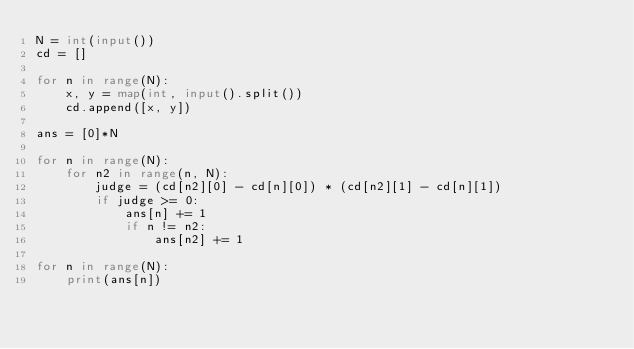<code> <loc_0><loc_0><loc_500><loc_500><_Python_>N = int(input())
cd = []

for n in range(N):
    x, y = map(int, input().split())
    cd.append([x, y])

ans = [0]*N

for n in range(N):
    for n2 in range(n, N):
        judge = (cd[n2][0] - cd[n][0]) * (cd[n2][1] - cd[n][1])
        if judge >= 0:
            ans[n] += 1
            if n != n2:
                ans[n2] += 1

for n in range(N):
    print(ans[n])</code> 